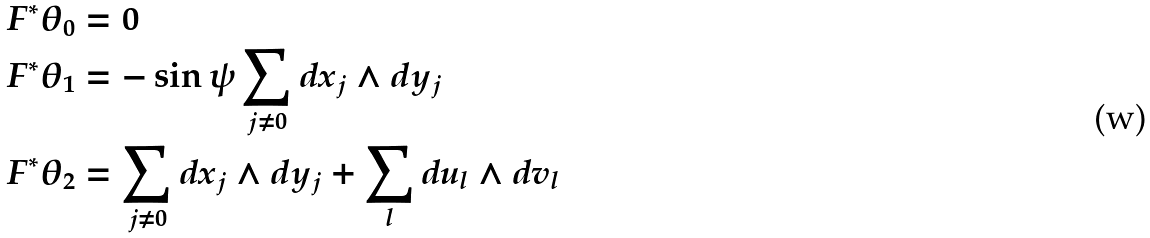Convert formula to latex. <formula><loc_0><loc_0><loc_500><loc_500>F ^ { * } \theta _ { 0 } & = 0 \\ F ^ { * } \theta _ { 1 } & = - \sin \psi \sum _ { j \ne 0 } d x _ { j } \wedge d y _ { j } \\ F ^ { * } \theta _ { 2 } & = \sum _ { j \ne 0 } d x _ { j } \wedge d y _ { j } + \sum _ { l } d u _ { l } \wedge d v _ { l }</formula> 